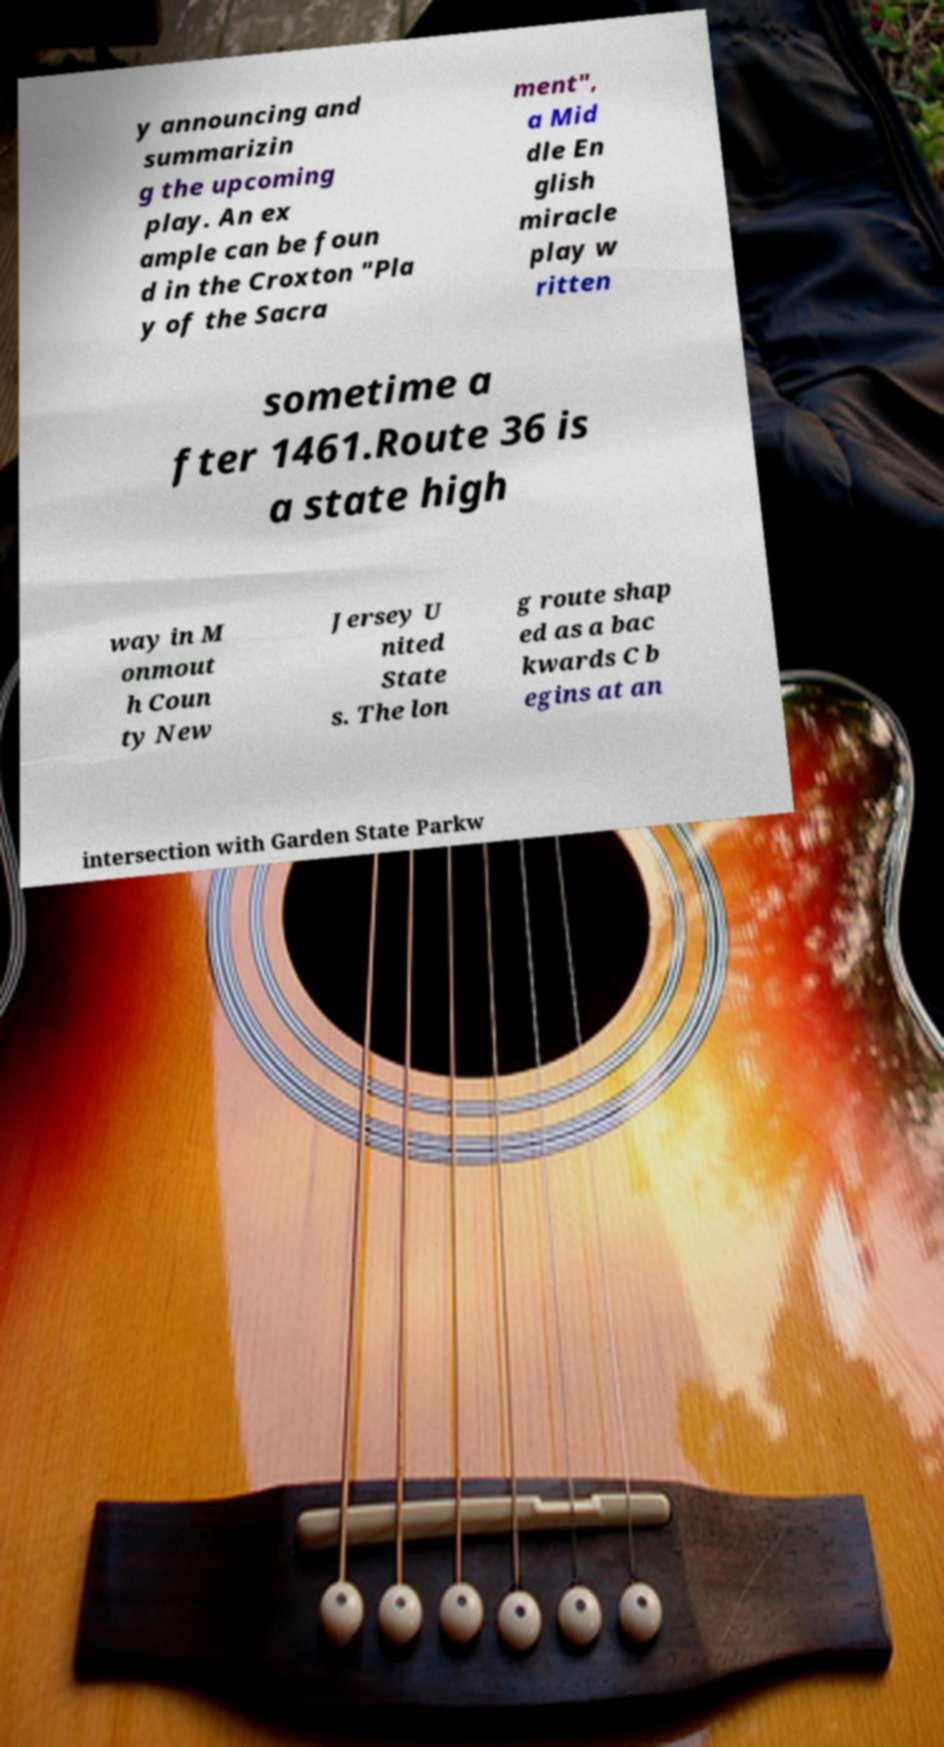Please identify and transcribe the text found in this image. y announcing and summarizin g the upcoming play. An ex ample can be foun d in the Croxton "Pla y of the Sacra ment", a Mid dle En glish miracle play w ritten sometime a fter 1461.Route 36 is a state high way in M onmout h Coun ty New Jersey U nited State s. The lon g route shap ed as a bac kwards C b egins at an intersection with Garden State Parkw 